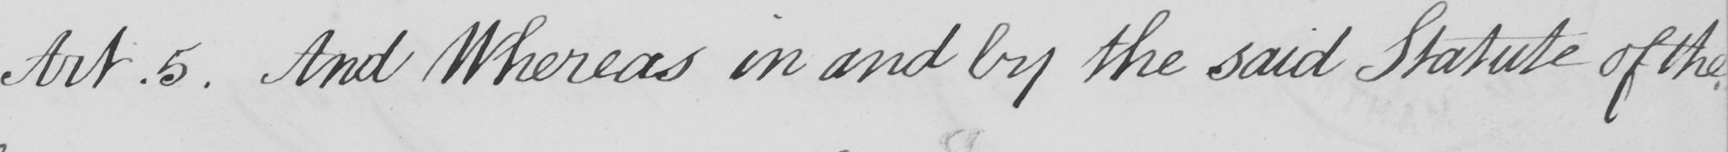Can you tell me what this handwritten text says? Art . 5 . And Whereas in and by the said Statue of the 